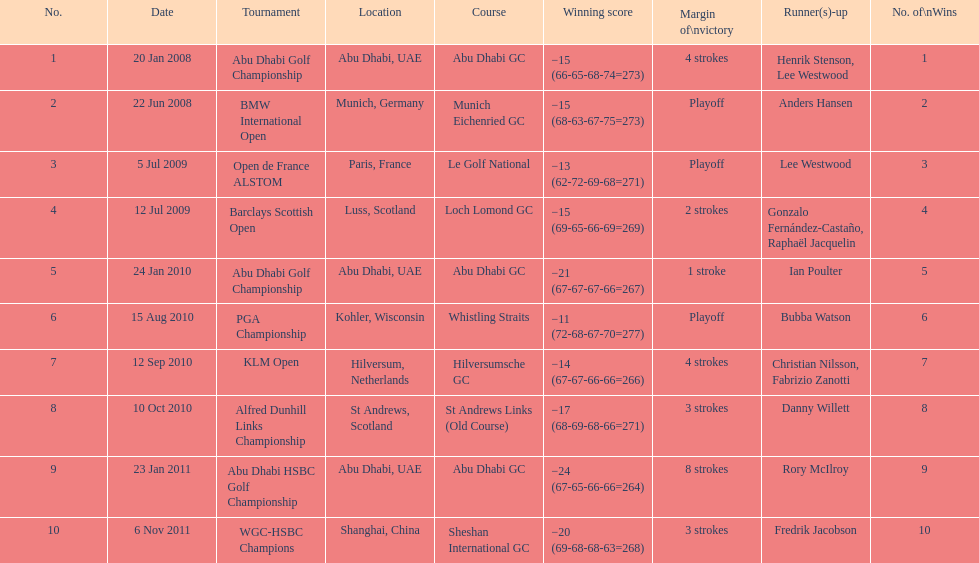How long separated the playoff victory at bmw international open and the 4 stroke victory at the klm open? 2 years. 